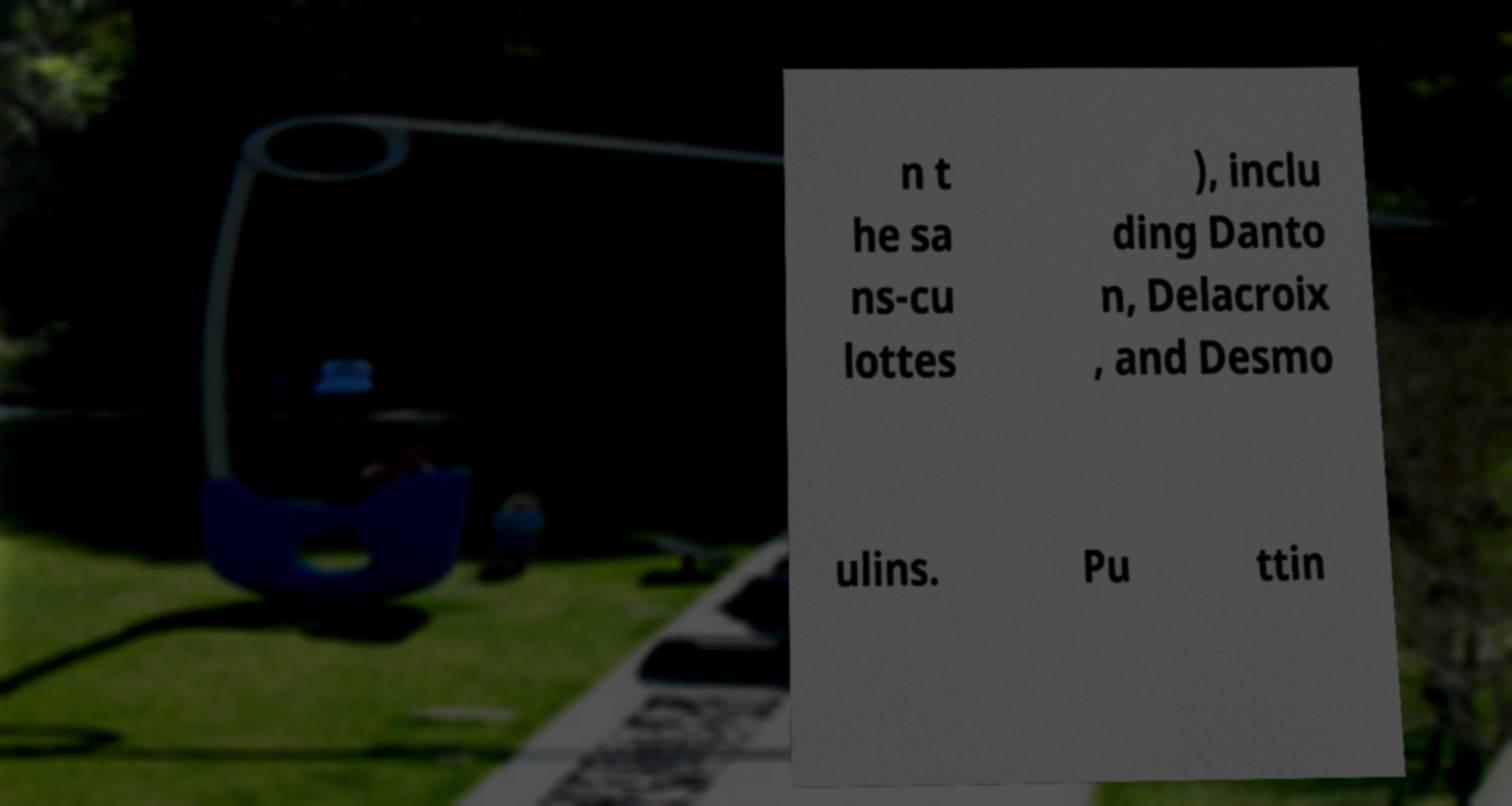What messages or text are displayed in this image? I need them in a readable, typed format. n t he sa ns-cu lottes ), inclu ding Danto n, Delacroix , and Desmo ulins. Pu ttin 